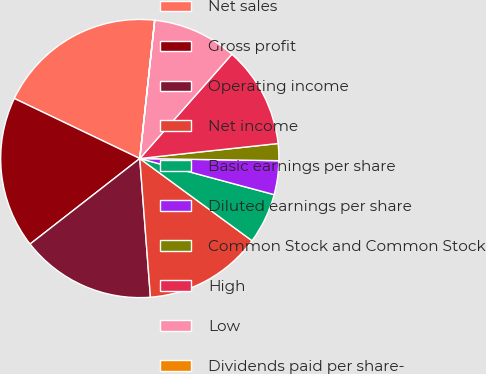Convert chart. <chart><loc_0><loc_0><loc_500><loc_500><pie_chart><fcel>Net sales<fcel>Gross profit<fcel>Operating income<fcel>Net income<fcel>Basic earnings per share<fcel>Diluted earnings per share<fcel>Common Stock and Common Stock<fcel>High<fcel>Low<fcel>Dividends paid per share-<nl><fcel>19.6%<fcel>17.64%<fcel>15.68%<fcel>13.72%<fcel>5.88%<fcel>3.93%<fcel>1.97%<fcel>11.76%<fcel>9.8%<fcel>0.01%<nl></chart> 